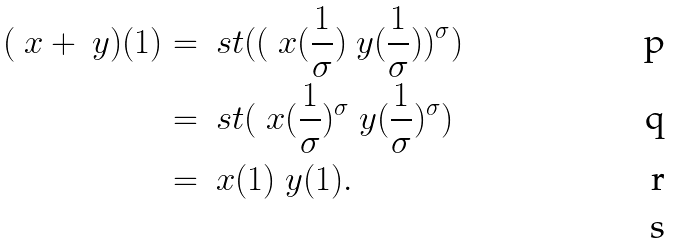Convert formula to latex. <formula><loc_0><loc_0><loc_500><loc_500>( \ x + \ y ) ( 1 ) & = \ s t ( ( \ x ( \frac { 1 } { \sigma } ) \ y ( \frac { 1 } { \sigma } ) ) ^ { \sigma } ) \\ & = \ s t ( \ x ( \frac { 1 } { \sigma } ) ^ { \sigma } \ y ( \frac { 1 } { \sigma } ) ^ { \sigma } ) \\ & = \ x ( 1 ) \ y ( 1 ) . \\</formula> 